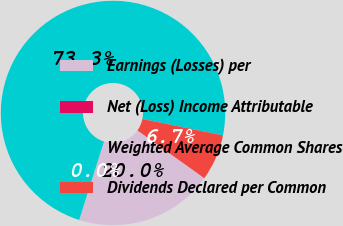Convert chart to OTSL. <chart><loc_0><loc_0><loc_500><loc_500><pie_chart><fcel>Earnings (Losses) per<fcel>Net (Loss) Income Attributable<fcel>Weighted Average Common Shares<fcel>Dividends Declared per Common<nl><fcel>20.0%<fcel>0.0%<fcel>73.33%<fcel>6.67%<nl></chart> 